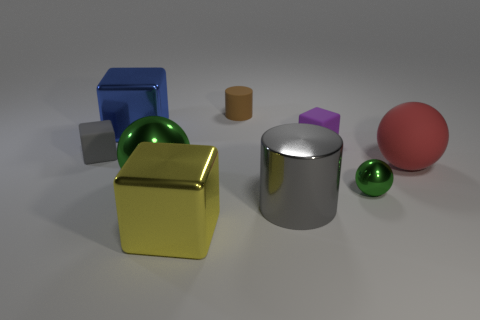Could you describe a possible physics experiment that involves these objects? Certainly. An interesting physics experiment with these objects could involve exploring the concepts of mass, density, and buoyancy. By hypothetically submerging these objects in water, students could predict and observe which shapes float or sink, how they displace water, and relate these observations to the materials' properties and geometric shapes. 